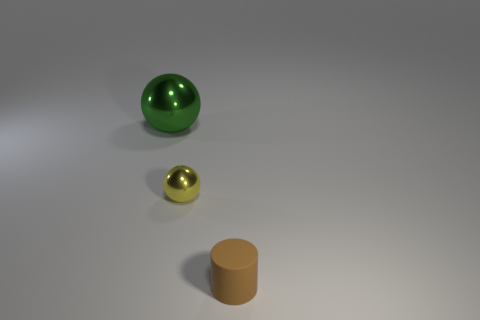The other metallic thing that is the same shape as the tiny metallic thing is what size?
Give a very brief answer. Large. There is a yellow metal object; is its size the same as the metal sphere on the left side of the yellow sphere?
Your answer should be compact. No. Are there any brown rubber cylinders that have the same size as the yellow shiny thing?
Provide a succinct answer. Yes. How many objects are either large blue rubber spheres or small metal things?
Provide a short and direct response. 1. There is a ball in front of the green object; does it have the same size as the thing in front of the yellow thing?
Give a very brief answer. Yes. Are there any tiny metallic things of the same shape as the big green shiny object?
Keep it short and to the point. Yes. Are there fewer yellow objects that are to the left of the large green thing than small gray metallic balls?
Make the answer very short. No. Is the yellow shiny thing the same shape as the green metallic object?
Provide a succinct answer. Yes. What is the size of the shiny object in front of the green metal ball?
Provide a short and direct response. Small. The other sphere that is the same material as the green sphere is what size?
Give a very brief answer. Small. 